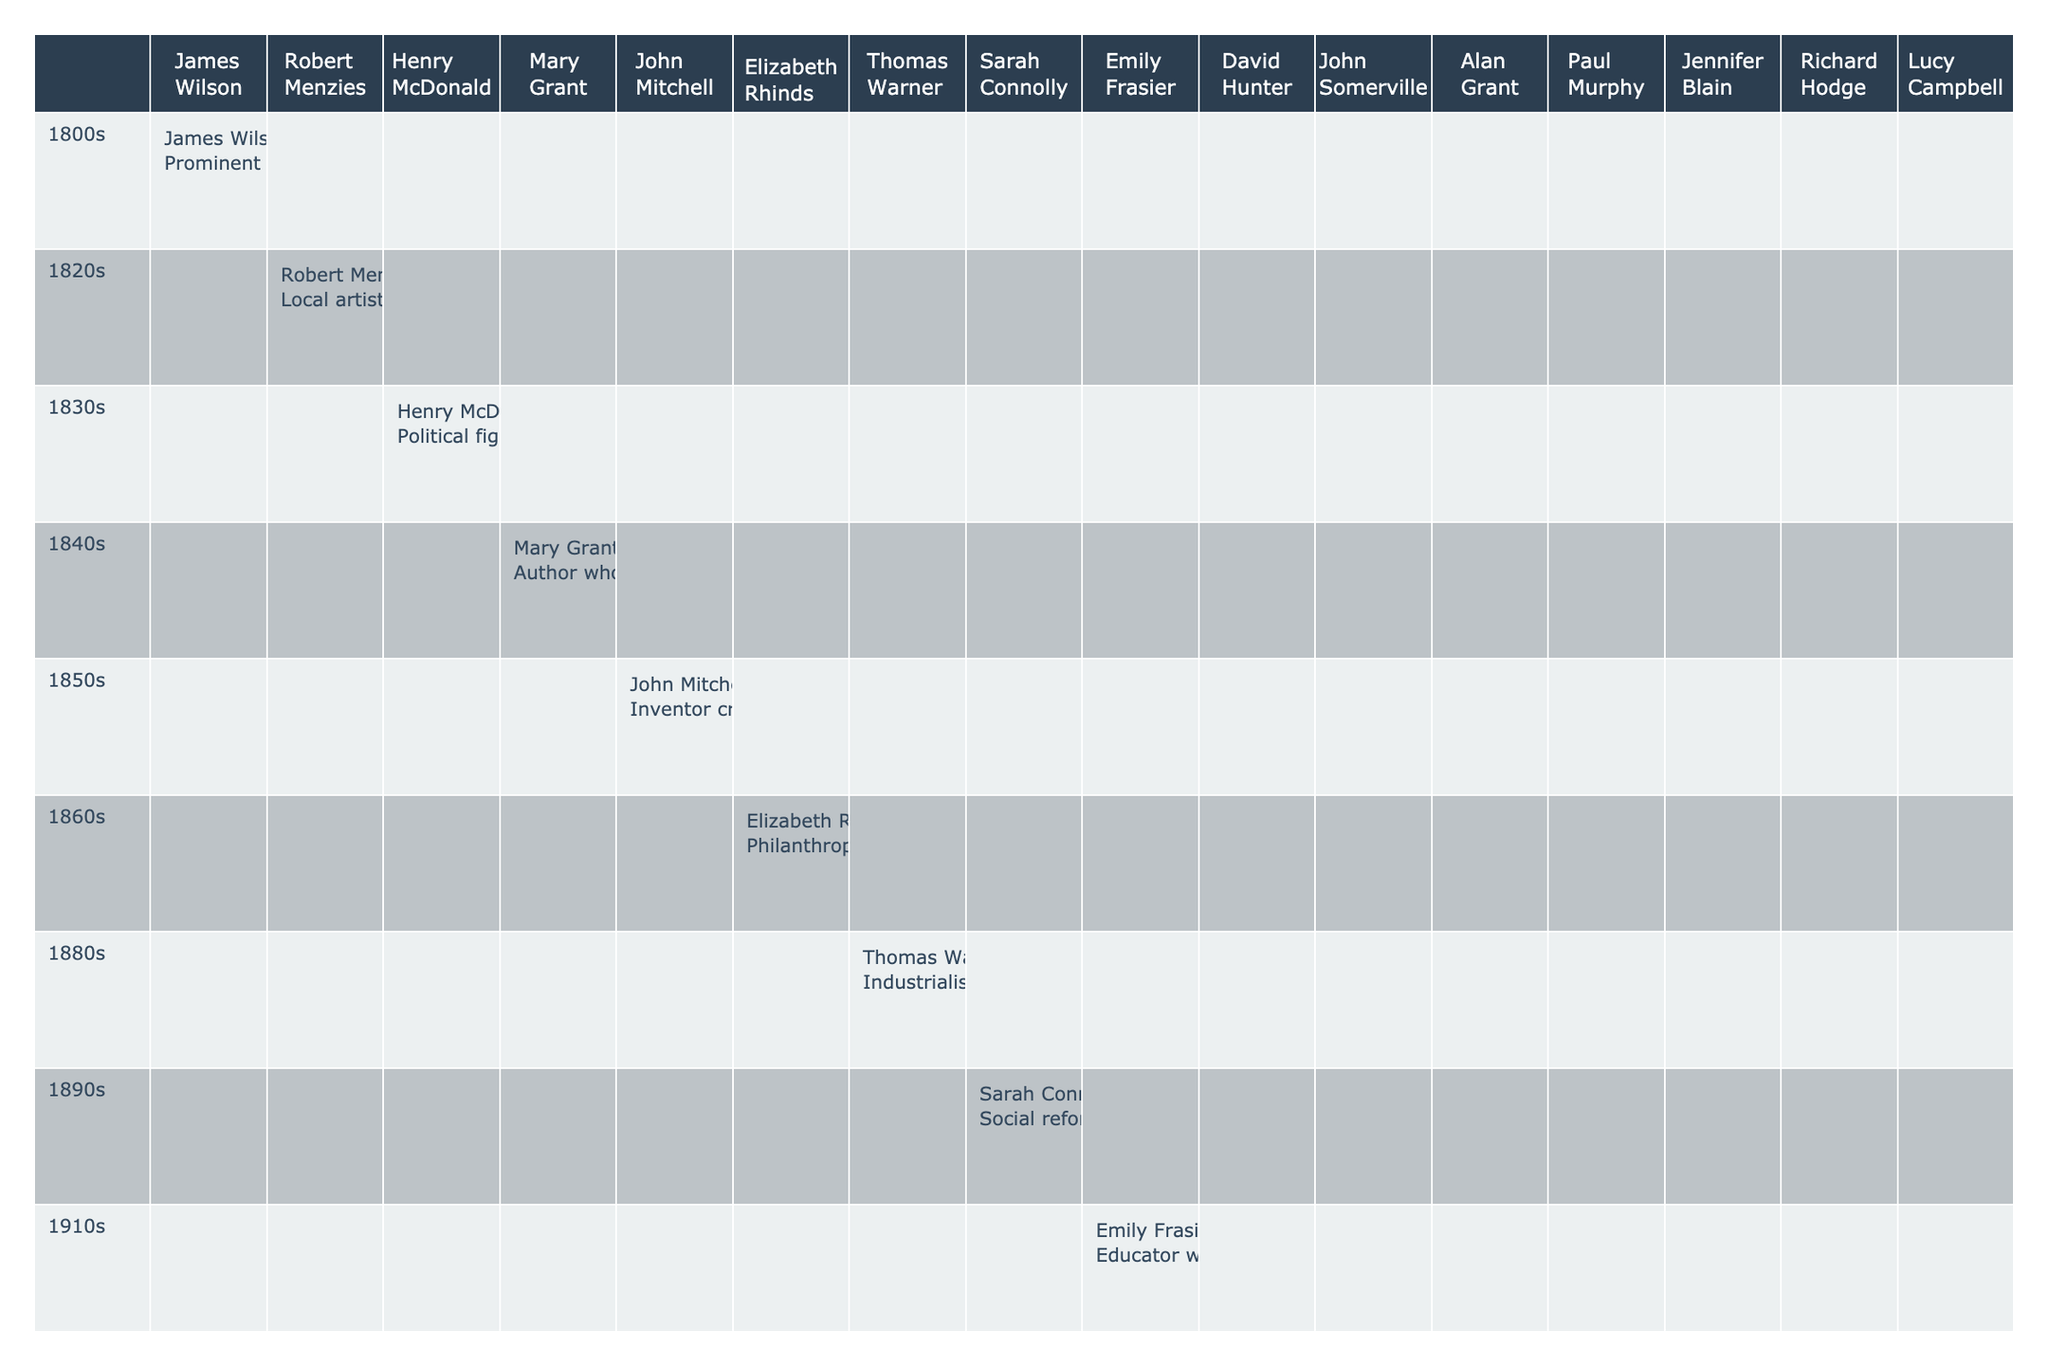What contributions did Sarah Connolly make in the 1890s? The table shows that Sarah Connolly was a social reformer advocating for better working conditions in the local textile industry during the 1890s.
Answer: Social reformer advocating for better working conditions Who was the philanthropist in the 1860s? The table indicates that Elizabeth Rhinds was the philanthropist who funded the building of St. John's Church in Pitlurg during the 1860s.
Answer: Elizabeth Rhinds Which decade saw contributions from both an artist and an author? The 1820s had Robert Menzies, a local artist known for his landscape paintings, and the 1840s featured Mary Grant, an author who wrote about rural life in Pitlurg.
Answer: 1820s and 1840s Did any figure from the 1940s contribute during or after World War II? Yes, John Somerville, a military leader and war hero, is noted in the table for his bravery and respect in the community post-WWII.
Answer: Yes How many decades are represented in the contributions? The table lists contributions from the 1800s through the 2010s, which encompasses 12 decades in total.
Answer: 12 decades Which notable figure contributed to education in the 1910s? The table shows that Emily Frasier was the educator who introduced innovative teaching methods in Pitlurg schools during the 1910s.
Answer: Emily Frasier Was there anyone known for conservation efforts in the 1960s? Yes, Alan Grant is mentioned as an environmentalist focused on conservation efforts for local wildlife habitats in the 1960s.
Answer: Yes Who contributed the earliest in the timeline, and what was their contribution? The data indicates that James Wilson contributed in the 1800s by advocating for local agricultural practices and crop rotation methods.
Answer: James Wilson, advocating for local agricultural practices What was the main focus of Paul Murphy's contributions in the 1980s? According to the table, Paul Murphy was a community activist focusing on social justice and equality in Pitlurg.
Answer: Social justice and equality activism How many contributions are related to the arts across all decades? The contributions related to the arts include Robert Menzies in the 1820s (artist) and Lucy Campbell in the 2010s (arts advocate). This totals to two contributions.
Answer: 2 contributions 